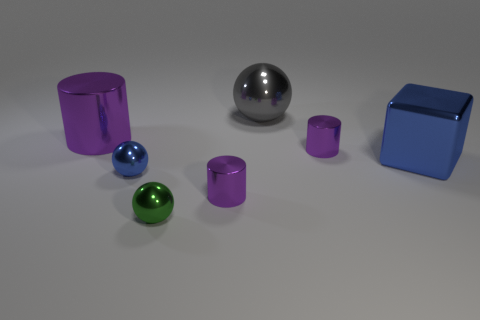Subtract all purple cylinders. How many were subtracted if there are1purple cylinders left? 2 Add 1 large purple balls. How many objects exist? 8 Subtract all cylinders. How many objects are left? 4 Add 6 large gray spheres. How many large gray spheres exist? 7 Subtract 1 blue balls. How many objects are left? 6 Subtract all metal blocks. Subtract all small blue spheres. How many objects are left? 5 Add 5 cylinders. How many cylinders are left? 8 